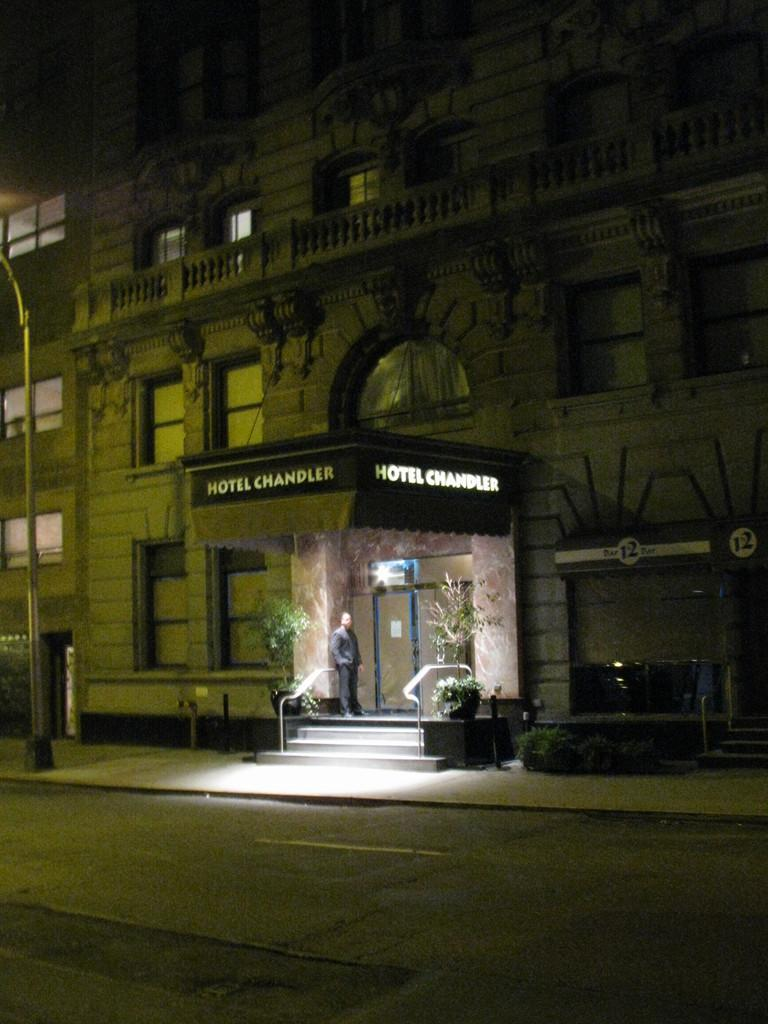What structure is the main subject of the image? There is a building in the image. What feature can be seen on the building? The building has windows. Who is present near the building? There is a person standing at the door of the building. What can be seen in the background of the image? There is a road visible in the image. Can you tell me how many toes the zephyr has in the image? There is no zephyr present in the image, and therefore no toes can be counted. 